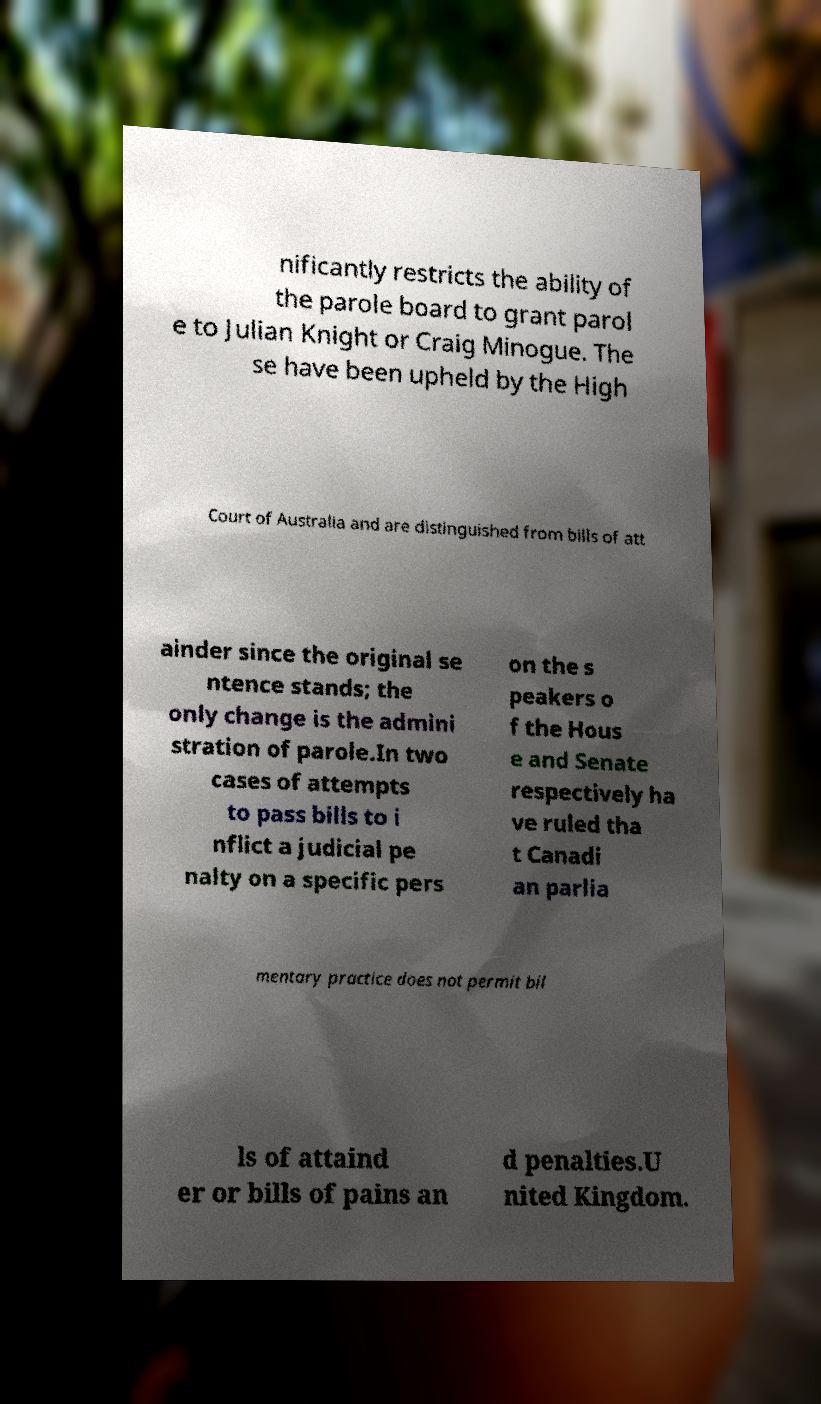I need the written content from this picture converted into text. Can you do that? nificantly restricts the ability of the parole board to grant parol e to Julian Knight or Craig Minogue. The se have been upheld by the High Court of Australia and are distinguished from bills of att ainder since the original se ntence stands; the only change is the admini stration of parole.In two cases of attempts to pass bills to i nflict a judicial pe nalty on a specific pers on the s peakers o f the Hous e and Senate respectively ha ve ruled tha t Canadi an parlia mentary practice does not permit bil ls of attaind er or bills of pains an d penalties.U nited Kingdom. 